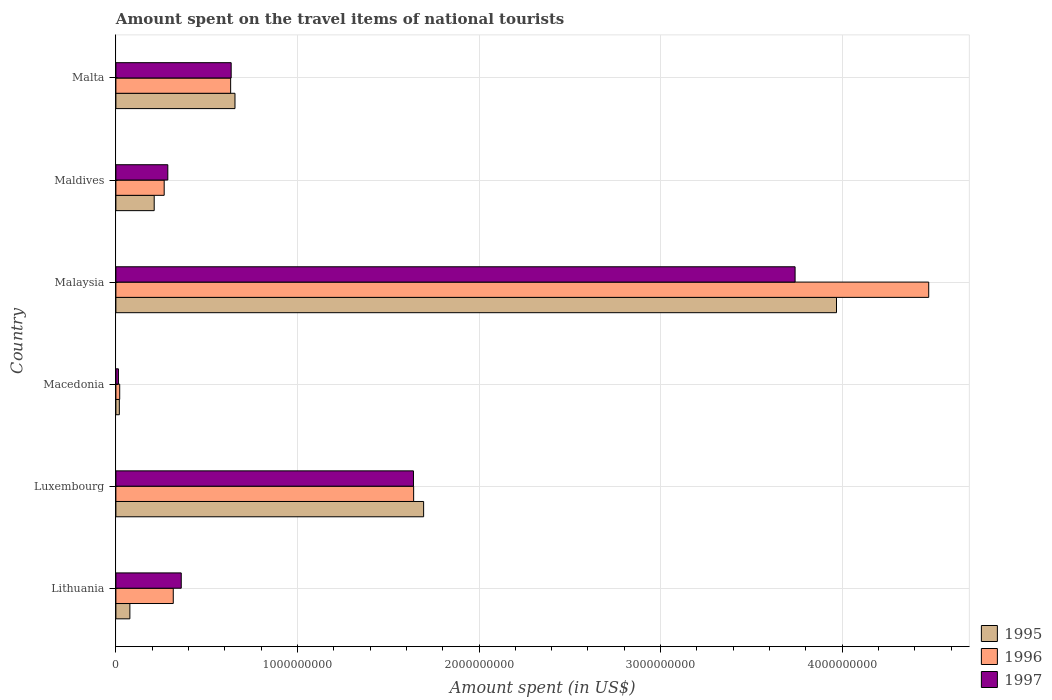How many different coloured bars are there?
Offer a terse response. 3. How many groups of bars are there?
Make the answer very short. 6. Are the number of bars per tick equal to the number of legend labels?
Make the answer very short. Yes. How many bars are there on the 2nd tick from the top?
Make the answer very short. 3. How many bars are there on the 2nd tick from the bottom?
Your answer should be compact. 3. What is the label of the 1st group of bars from the top?
Keep it short and to the point. Malta. What is the amount spent on the travel items of national tourists in 1996 in Malta?
Keep it short and to the point. 6.32e+08. Across all countries, what is the maximum amount spent on the travel items of national tourists in 1995?
Give a very brief answer. 3.97e+09. Across all countries, what is the minimum amount spent on the travel items of national tourists in 1997?
Keep it short and to the point. 1.40e+07. In which country was the amount spent on the travel items of national tourists in 1997 maximum?
Make the answer very short. Malaysia. In which country was the amount spent on the travel items of national tourists in 1995 minimum?
Make the answer very short. Macedonia. What is the total amount spent on the travel items of national tourists in 1997 in the graph?
Your response must be concise. 6.68e+09. What is the difference between the amount spent on the travel items of national tourists in 1996 in Macedonia and that in Malta?
Your response must be concise. -6.11e+08. What is the difference between the amount spent on the travel items of national tourists in 1995 in Malaysia and the amount spent on the travel items of national tourists in 1996 in Lithuania?
Your response must be concise. 3.65e+09. What is the average amount spent on the travel items of national tourists in 1996 per country?
Offer a very short reply. 1.23e+09. What is the difference between the amount spent on the travel items of national tourists in 1995 and amount spent on the travel items of national tourists in 1996 in Maldives?
Offer a very short reply. -5.50e+07. What is the ratio of the amount spent on the travel items of national tourists in 1996 in Lithuania to that in Luxembourg?
Make the answer very short. 0.19. What is the difference between the highest and the second highest amount spent on the travel items of national tourists in 1996?
Your response must be concise. 2.84e+09. What is the difference between the highest and the lowest amount spent on the travel items of national tourists in 1995?
Give a very brief answer. 3.95e+09. In how many countries, is the amount spent on the travel items of national tourists in 1997 greater than the average amount spent on the travel items of national tourists in 1997 taken over all countries?
Provide a short and direct response. 2. Is the sum of the amount spent on the travel items of national tourists in 1997 in Macedonia and Malta greater than the maximum amount spent on the travel items of national tourists in 1995 across all countries?
Give a very brief answer. No. What does the 1st bar from the bottom in Lithuania represents?
Keep it short and to the point. 1995. Are all the bars in the graph horizontal?
Your answer should be compact. Yes. How many countries are there in the graph?
Ensure brevity in your answer.  6. Does the graph contain any zero values?
Make the answer very short. No. Does the graph contain grids?
Your response must be concise. Yes. What is the title of the graph?
Ensure brevity in your answer.  Amount spent on the travel items of national tourists. Does "1962" appear as one of the legend labels in the graph?
Provide a succinct answer. No. What is the label or title of the X-axis?
Ensure brevity in your answer.  Amount spent (in US$). What is the Amount spent (in US$) in 1995 in Lithuania?
Your response must be concise. 7.70e+07. What is the Amount spent (in US$) in 1996 in Lithuania?
Provide a succinct answer. 3.16e+08. What is the Amount spent (in US$) of 1997 in Lithuania?
Provide a short and direct response. 3.60e+08. What is the Amount spent (in US$) of 1995 in Luxembourg?
Your answer should be compact. 1.70e+09. What is the Amount spent (in US$) of 1996 in Luxembourg?
Offer a terse response. 1.64e+09. What is the Amount spent (in US$) in 1997 in Luxembourg?
Make the answer very short. 1.64e+09. What is the Amount spent (in US$) in 1995 in Macedonia?
Your answer should be very brief. 1.90e+07. What is the Amount spent (in US$) of 1996 in Macedonia?
Offer a very short reply. 2.10e+07. What is the Amount spent (in US$) in 1997 in Macedonia?
Provide a short and direct response. 1.40e+07. What is the Amount spent (in US$) of 1995 in Malaysia?
Make the answer very short. 3.97e+09. What is the Amount spent (in US$) in 1996 in Malaysia?
Provide a short and direct response. 4.48e+09. What is the Amount spent (in US$) in 1997 in Malaysia?
Provide a succinct answer. 3.74e+09. What is the Amount spent (in US$) in 1995 in Maldives?
Provide a succinct answer. 2.11e+08. What is the Amount spent (in US$) of 1996 in Maldives?
Offer a very short reply. 2.66e+08. What is the Amount spent (in US$) in 1997 in Maldives?
Your response must be concise. 2.86e+08. What is the Amount spent (in US$) of 1995 in Malta?
Ensure brevity in your answer.  6.56e+08. What is the Amount spent (in US$) of 1996 in Malta?
Keep it short and to the point. 6.32e+08. What is the Amount spent (in US$) of 1997 in Malta?
Keep it short and to the point. 6.35e+08. Across all countries, what is the maximum Amount spent (in US$) in 1995?
Provide a succinct answer. 3.97e+09. Across all countries, what is the maximum Amount spent (in US$) in 1996?
Offer a very short reply. 4.48e+09. Across all countries, what is the maximum Amount spent (in US$) in 1997?
Your response must be concise. 3.74e+09. Across all countries, what is the minimum Amount spent (in US$) of 1995?
Your answer should be very brief. 1.90e+07. Across all countries, what is the minimum Amount spent (in US$) of 1996?
Your answer should be very brief. 2.10e+07. Across all countries, what is the minimum Amount spent (in US$) in 1997?
Your answer should be compact. 1.40e+07. What is the total Amount spent (in US$) of 1995 in the graph?
Your answer should be very brief. 6.63e+09. What is the total Amount spent (in US$) of 1996 in the graph?
Provide a short and direct response. 7.35e+09. What is the total Amount spent (in US$) in 1997 in the graph?
Offer a very short reply. 6.68e+09. What is the difference between the Amount spent (in US$) of 1995 in Lithuania and that in Luxembourg?
Make the answer very short. -1.62e+09. What is the difference between the Amount spent (in US$) of 1996 in Lithuania and that in Luxembourg?
Provide a succinct answer. -1.32e+09. What is the difference between the Amount spent (in US$) of 1997 in Lithuania and that in Luxembourg?
Offer a terse response. -1.28e+09. What is the difference between the Amount spent (in US$) in 1995 in Lithuania and that in Macedonia?
Offer a terse response. 5.80e+07. What is the difference between the Amount spent (in US$) in 1996 in Lithuania and that in Macedonia?
Give a very brief answer. 2.95e+08. What is the difference between the Amount spent (in US$) of 1997 in Lithuania and that in Macedonia?
Provide a short and direct response. 3.46e+08. What is the difference between the Amount spent (in US$) of 1995 in Lithuania and that in Malaysia?
Offer a very short reply. -3.89e+09. What is the difference between the Amount spent (in US$) in 1996 in Lithuania and that in Malaysia?
Your answer should be very brief. -4.16e+09. What is the difference between the Amount spent (in US$) of 1997 in Lithuania and that in Malaysia?
Make the answer very short. -3.38e+09. What is the difference between the Amount spent (in US$) of 1995 in Lithuania and that in Maldives?
Give a very brief answer. -1.34e+08. What is the difference between the Amount spent (in US$) of 1996 in Lithuania and that in Maldives?
Make the answer very short. 5.00e+07. What is the difference between the Amount spent (in US$) of 1997 in Lithuania and that in Maldives?
Your answer should be compact. 7.40e+07. What is the difference between the Amount spent (in US$) in 1995 in Lithuania and that in Malta?
Keep it short and to the point. -5.79e+08. What is the difference between the Amount spent (in US$) in 1996 in Lithuania and that in Malta?
Provide a short and direct response. -3.16e+08. What is the difference between the Amount spent (in US$) in 1997 in Lithuania and that in Malta?
Your answer should be compact. -2.75e+08. What is the difference between the Amount spent (in US$) in 1995 in Luxembourg and that in Macedonia?
Ensure brevity in your answer.  1.68e+09. What is the difference between the Amount spent (in US$) in 1996 in Luxembourg and that in Macedonia?
Provide a short and direct response. 1.62e+09. What is the difference between the Amount spent (in US$) of 1997 in Luxembourg and that in Macedonia?
Offer a terse response. 1.62e+09. What is the difference between the Amount spent (in US$) in 1995 in Luxembourg and that in Malaysia?
Offer a terse response. -2.27e+09. What is the difference between the Amount spent (in US$) in 1996 in Luxembourg and that in Malaysia?
Your response must be concise. -2.84e+09. What is the difference between the Amount spent (in US$) of 1997 in Luxembourg and that in Malaysia?
Make the answer very short. -2.10e+09. What is the difference between the Amount spent (in US$) in 1995 in Luxembourg and that in Maldives?
Provide a short and direct response. 1.48e+09. What is the difference between the Amount spent (in US$) of 1996 in Luxembourg and that in Maldives?
Offer a terse response. 1.37e+09. What is the difference between the Amount spent (in US$) in 1997 in Luxembourg and that in Maldives?
Your answer should be compact. 1.35e+09. What is the difference between the Amount spent (in US$) in 1995 in Luxembourg and that in Malta?
Ensure brevity in your answer.  1.04e+09. What is the difference between the Amount spent (in US$) in 1996 in Luxembourg and that in Malta?
Offer a very short reply. 1.01e+09. What is the difference between the Amount spent (in US$) in 1997 in Luxembourg and that in Malta?
Your answer should be compact. 1.00e+09. What is the difference between the Amount spent (in US$) in 1995 in Macedonia and that in Malaysia?
Ensure brevity in your answer.  -3.95e+09. What is the difference between the Amount spent (in US$) in 1996 in Macedonia and that in Malaysia?
Your answer should be very brief. -4.46e+09. What is the difference between the Amount spent (in US$) in 1997 in Macedonia and that in Malaysia?
Your response must be concise. -3.73e+09. What is the difference between the Amount spent (in US$) in 1995 in Macedonia and that in Maldives?
Offer a very short reply. -1.92e+08. What is the difference between the Amount spent (in US$) in 1996 in Macedonia and that in Maldives?
Ensure brevity in your answer.  -2.45e+08. What is the difference between the Amount spent (in US$) of 1997 in Macedonia and that in Maldives?
Ensure brevity in your answer.  -2.72e+08. What is the difference between the Amount spent (in US$) of 1995 in Macedonia and that in Malta?
Provide a short and direct response. -6.37e+08. What is the difference between the Amount spent (in US$) of 1996 in Macedonia and that in Malta?
Your answer should be very brief. -6.11e+08. What is the difference between the Amount spent (in US$) in 1997 in Macedonia and that in Malta?
Offer a terse response. -6.21e+08. What is the difference between the Amount spent (in US$) in 1995 in Malaysia and that in Maldives?
Your response must be concise. 3.76e+09. What is the difference between the Amount spent (in US$) in 1996 in Malaysia and that in Maldives?
Keep it short and to the point. 4.21e+09. What is the difference between the Amount spent (in US$) of 1997 in Malaysia and that in Maldives?
Offer a very short reply. 3.46e+09. What is the difference between the Amount spent (in US$) in 1995 in Malaysia and that in Malta?
Provide a succinct answer. 3.31e+09. What is the difference between the Amount spent (in US$) of 1996 in Malaysia and that in Malta?
Give a very brief answer. 3.84e+09. What is the difference between the Amount spent (in US$) in 1997 in Malaysia and that in Malta?
Give a very brief answer. 3.11e+09. What is the difference between the Amount spent (in US$) in 1995 in Maldives and that in Malta?
Give a very brief answer. -4.45e+08. What is the difference between the Amount spent (in US$) of 1996 in Maldives and that in Malta?
Your response must be concise. -3.66e+08. What is the difference between the Amount spent (in US$) of 1997 in Maldives and that in Malta?
Your answer should be very brief. -3.49e+08. What is the difference between the Amount spent (in US$) of 1995 in Lithuania and the Amount spent (in US$) of 1996 in Luxembourg?
Provide a succinct answer. -1.56e+09. What is the difference between the Amount spent (in US$) in 1995 in Lithuania and the Amount spent (in US$) in 1997 in Luxembourg?
Your response must be concise. -1.56e+09. What is the difference between the Amount spent (in US$) in 1996 in Lithuania and the Amount spent (in US$) in 1997 in Luxembourg?
Keep it short and to the point. -1.32e+09. What is the difference between the Amount spent (in US$) of 1995 in Lithuania and the Amount spent (in US$) of 1996 in Macedonia?
Provide a succinct answer. 5.60e+07. What is the difference between the Amount spent (in US$) of 1995 in Lithuania and the Amount spent (in US$) of 1997 in Macedonia?
Your answer should be very brief. 6.30e+07. What is the difference between the Amount spent (in US$) of 1996 in Lithuania and the Amount spent (in US$) of 1997 in Macedonia?
Give a very brief answer. 3.02e+08. What is the difference between the Amount spent (in US$) of 1995 in Lithuania and the Amount spent (in US$) of 1996 in Malaysia?
Offer a terse response. -4.40e+09. What is the difference between the Amount spent (in US$) in 1995 in Lithuania and the Amount spent (in US$) in 1997 in Malaysia?
Offer a terse response. -3.66e+09. What is the difference between the Amount spent (in US$) of 1996 in Lithuania and the Amount spent (in US$) of 1997 in Malaysia?
Your answer should be very brief. -3.42e+09. What is the difference between the Amount spent (in US$) in 1995 in Lithuania and the Amount spent (in US$) in 1996 in Maldives?
Keep it short and to the point. -1.89e+08. What is the difference between the Amount spent (in US$) of 1995 in Lithuania and the Amount spent (in US$) of 1997 in Maldives?
Offer a terse response. -2.09e+08. What is the difference between the Amount spent (in US$) of 1996 in Lithuania and the Amount spent (in US$) of 1997 in Maldives?
Make the answer very short. 3.00e+07. What is the difference between the Amount spent (in US$) in 1995 in Lithuania and the Amount spent (in US$) in 1996 in Malta?
Keep it short and to the point. -5.55e+08. What is the difference between the Amount spent (in US$) of 1995 in Lithuania and the Amount spent (in US$) of 1997 in Malta?
Your response must be concise. -5.58e+08. What is the difference between the Amount spent (in US$) in 1996 in Lithuania and the Amount spent (in US$) in 1997 in Malta?
Your response must be concise. -3.19e+08. What is the difference between the Amount spent (in US$) of 1995 in Luxembourg and the Amount spent (in US$) of 1996 in Macedonia?
Your response must be concise. 1.67e+09. What is the difference between the Amount spent (in US$) in 1995 in Luxembourg and the Amount spent (in US$) in 1997 in Macedonia?
Provide a succinct answer. 1.68e+09. What is the difference between the Amount spent (in US$) in 1996 in Luxembourg and the Amount spent (in US$) in 1997 in Macedonia?
Your answer should be very brief. 1.63e+09. What is the difference between the Amount spent (in US$) in 1995 in Luxembourg and the Amount spent (in US$) in 1996 in Malaysia?
Give a very brief answer. -2.78e+09. What is the difference between the Amount spent (in US$) in 1995 in Luxembourg and the Amount spent (in US$) in 1997 in Malaysia?
Offer a terse response. -2.05e+09. What is the difference between the Amount spent (in US$) in 1996 in Luxembourg and the Amount spent (in US$) in 1997 in Malaysia?
Provide a succinct answer. -2.10e+09. What is the difference between the Amount spent (in US$) of 1995 in Luxembourg and the Amount spent (in US$) of 1996 in Maldives?
Offer a very short reply. 1.43e+09. What is the difference between the Amount spent (in US$) in 1995 in Luxembourg and the Amount spent (in US$) in 1997 in Maldives?
Provide a short and direct response. 1.41e+09. What is the difference between the Amount spent (in US$) in 1996 in Luxembourg and the Amount spent (in US$) in 1997 in Maldives?
Your answer should be very brief. 1.35e+09. What is the difference between the Amount spent (in US$) of 1995 in Luxembourg and the Amount spent (in US$) of 1996 in Malta?
Offer a very short reply. 1.06e+09. What is the difference between the Amount spent (in US$) in 1995 in Luxembourg and the Amount spent (in US$) in 1997 in Malta?
Your answer should be compact. 1.06e+09. What is the difference between the Amount spent (in US$) in 1996 in Luxembourg and the Amount spent (in US$) in 1997 in Malta?
Your answer should be very brief. 1.00e+09. What is the difference between the Amount spent (in US$) in 1995 in Macedonia and the Amount spent (in US$) in 1996 in Malaysia?
Provide a short and direct response. -4.46e+09. What is the difference between the Amount spent (in US$) of 1995 in Macedonia and the Amount spent (in US$) of 1997 in Malaysia?
Your answer should be very brief. -3.72e+09. What is the difference between the Amount spent (in US$) in 1996 in Macedonia and the Amount spent (in US$) in 1997 in Malaysia?
Give a very brief answer. -3.72e+09. What is the difference between the Amount spent (in US$) of 1995 in Macedonia and the Amount spent (in US$) of 1996 in Maldives?
Give a very brief answer. -2.47e+08. What is the difference between the Amount spent (in US$) of 1995 in Macedonia and the Amount spent (in US$) of 1997 in Maldives?
Provide a succinct answer. -2.67e+08. What is the difference between the Amount spent (in US$) in 1996 in Macedonia and the Amount spent (in US$) in 1997 in Maldives?
Your answer should be compact. -2.65e+08. What is the difference between the Amount spent (in US$) of 1995 in Macedonia and the Amount spent (in US$) of 1996 in Malta?
Your response must be concise. -6.13e+08. What is the difference between the Amount spent (in US$) in 1995 in Macedonia and the Amount spent (in US$) in 1997 in Malta?
Provide a succinct answer. -6.16e+08. What is the difference between the Amount spent (in US$) in 1996 in Macedonia and the Amount spent (in US$) in 1997 in Malta?
Your answer should be compact. -6.14e+08. What is the difference between the Amount spent (in US$) in 1995 in Malaysia and the Amount spent (in US$) in 1996 in Maldives?
Your answer should be very brief. 3.70e+09. What is the difference between the Amount spent (in US$) of 1995 in Malaysia and the Amount spent (in US$) of 1997 in Maldives?
Provide a short and direct response. 3.68e+09. What is the difference between the Amount spent (in US$) of 1996 in Malaysia and the Amount spent (in US$) of 1997 in Maldives?
Your response must be concise. 4.19e+09. What is the difference between the Amount spent (in US$) of 1995 in Malaysia and the Amount spent (in US$) of 1996 in Malta?
Ensure brevity in your answer.  3.34e+09. What is the difference between the Amount spent (in US$) in 1995 in Malaysia and the Amount spent (in US$) in 1997 in Malta?
Offer a very short reply. 3.33e+09. What is the difference between the Amount spent (in US$) of 1996 in Malaysia and the Amount spent (in US$) of 1997 in Malta?
Ensure brevity in your answer.  3.84e+09. What is the difference between the Amount spent (in US$) in 1995 in Maldives and the Amount spent (in US$) in 1996 in Malta?
Keep it short and to the point. -4.21e+08. What is the difference between the Amount spent (in US$) of 1995 in Maldives and the Amount spent (in US$) of 1997 in Malta?
Your answer should be compact. -4.24e+08. What is the difference between the Amount spent (in US$) of 1996 in Maldives and the Amount spent (in US$) of 1997 in Malta?
Your response must be concise. -3.69e+08. What is the average Amount spent (in US$) in 1995 per country?
Offer a very short reply. 1.10e+09. What is the average Amount spent (in US$) of 1996 per country?
Keep it short and to the point. 1.23e+09. What is the average Amount spent (in US$) of 1997 per country?
Keep it short and to the point. 1.11e+09. What is the difference between the Amount spent (in US$) in 1995 and Amount spent (in US$) in 1996 in Lithuania?
Keep it short and to the point. -2.39e+08. What is the difference between the Amount spent (in US$) of 1995 and Amount spent (in US$) of 1997 in Lithuania?
Provide a succinct answer. -2.83e+08. What is the difference between the Amount spent (in US$) of 1996 and Amount spent (in US$) of 1997 in Lithuania?
Your answer should be very brief. -4.40e+07. What is the difference between the Amount spent (in US$) of 1995 and Amount spent (in US$) of 1996 in Luxembourg?
Offer a very short reply. 5.50e+07. What is the difference between the Amount spent (in US$) in 1995 and Amount spent (in US$) in 1997 in Luxembourg?
Make the answer very short. 5.60e+07. What is the difference between the Amount spent (in US$) of 1996 and Amount spent (in US$) of 1997 in Luxembourg?
Your answer should be very brief. 1.00e+06. What is the difference between the Amount spent (in US$) of 1995 and Amount spent (in US$) of 1996 in Macedonia?
Offer a very short reply. -2.00e+06. What is the difference between the Amount spent (in US$) in 1995 and Amount spent (in US$) in 1997 in Macedonia?
Keep it short and to the point. 5.00e+06. What is the difference between the Amount spent (in US$) in 1996 and Amount spent (in US$) in 1997 in Macedonia?
Give a very brief answer. 7.00e+06. What is the difference between the Amount spent (in US$) of 1995 and Amount spent (in US$) of 1996 in Malaysia?
Offer a very short reply. -5.08e+08. What is the difference between the Amount spent (in US$) in 1995 and Amount spent (in US$) in 1997 in Malaysia?
Your answer should be very brief. 2.28e+08. What is the difference between the Amount spent (in US$) of 1996 and Amount spent (in US$) of 1997 in Malaysia?
Keep it short and to the point. 7.36e+08. What is the difference between the Amount spent (in US$) of 1995 and Amount spent (in US$) of 1996 in Maldives?
Offer a terse response. -5.50e+07. What is the difference between the Amount spent (in US$) in 1995 and Amount spent (in US$) in 1997 in Maldives?
Give a very brief answer. -7.50e+07. What is the difference between the Amount spent (in US$) in 1996 and Amount spent (in US$) in 1997 in Maldives?
Keep it short and to the point. -2.00e+07. What is the difference between the Amount spent (in US$) in 1995 and Amount spent (in US$) in 1996 in Malta?
Your answer should be very brief. 2.40e+07. What is the difference between the Amount spent (in US$) in 1995 and Amount spent (in US$) in 1997 in Malta?
Your response must be concise. 2.10e+07. What is the difference between the Amount spent (in US$) in 1996 and Amount spent (in US$) in 1997 in Malta?
Offer a terse response. -3.00e+06. What is the ratio of the Amount spent (in US$) of 1995 in Lithuania to that in Luxembourg?
Your answer should be compact. 0.05. What is the ratio of the Amount spent (in US$) of 1996 in Lithuania to that in Luxembourg?
Ensure brevity in your answer.  0.19. What is the ratio of the Amount spent (in US$) in 1997 in Lithuania to that in Luxembourg?
Give a very brief answer. 0.22. What is the ratio of the Amount spent (in US$) of 1995 in Lithuania to that in Macedonia?
Keep it short and to the point. 4.05. What is the ratio of the Amount spent (in US$) in 1996 in Lithuania to that in Macedonia?
Offer a very short reply. 15.05. What is the ratio of the Amount spent (in US$) in 1997 in Lithuania to that in Macedonia?
Keep it short and to the point. 25.71. What is the ratio of the Amount spent (in US$) of 1995 in Lithuania to that in Malaysia?
Your response must be concise. 0.02. What is the ratio of the Amount spent (in US$) of 1996 in Lithuania to that in Malaysia?
Make the answer very short. 0.07. What is the ratio of the Amount spent (in US$) of 1997 in Lithuania to that in Malaysia?
Provide a succinct answer. 0.1. What is the ratio of the Amount spent (in US$) in 1995 in Lithuania to that in Maldives?
Your response must be concise. 0.36. What is the ratio of the Amount spent (in US$) of 1996 in Lithuania to that in Maldives?
Your response must be concise. 1.19. What is the ratio of the Amount spent (in US$) in 1997 in Lithuania to that in Maldives?
Give a very brief answer. 1.26. What is the ratio of the Amount spent (in US$) of 1995 in Lithuania to that in Malta?
Keep it short and to the point. 0.12. What is the ratio of the Amount spent (in US$) in 1997 in Lithuania to that in Malta?
Your answer should be very brief. 0.57. What is the ratio of the Amount spent (in US$) of 1995 in Luxembourg to that in Macedonia?
Your answer should be very brief. 89.21. What is the ratio of the Amount spent (in US$) of 1996 in Luxembourg to that in Macedonia?
Offer a terse response. 78.1. What is the ratio of the Amount spent (in US$) of 1997 in Luxembourg to that in Macedonia?
Provide a short and direct response. 117.07. What is the ratio of the Amount spent (in US$) in 1995 in Luxembourg to that in Malaysia?
Offer a very short reply. 0.43. What is the ratio of the Amount spent (in US$) of 1996 in Luxembourg to that in Malaysia?
Your answer should be very brief. 0.37. What is the ratio of the Amount spent (in US$) in 1997 in Luxembourg to that in Malaysia?
Your answer should be compact. 0.44. What is the ratio of the Amount spent (in US$) in 1995 in Luxembourg to that in Maldives?
Ensure brevity in your answer.  8.03. What is the ratio of the Amount spent (in US$) in 1996 in Luxembourg to that in Maldives?
Offer a very short reply. 6.17. What is the ratio of the Amount spent (in US$) of 1997 in Luxembourg to that in Maldives?
Your response must be concise. 5.73. What is the ratio of the Amount spent (in US$) in 1995 in Luxembourg to that in Malta?
Offer a terse response. 2.58. What is the ratio of the Amount spent (in US$) of 1996 in Luxembourg to that in Malta?
Your answer should be very brief. 2.59. What is the ratio of the Amount spent (in US$) in 1997 in Luxembourg to that in Malta?
Provide a succinct answer. 2.58. What is the ratio of the Amount spent (in US$) of 1995 in Macedonia to that in Malaysia?
Provide a short and direct response. 0. What is the ratio of the Amount spent (in US$) in 1996 in Macedonia to that in Malaysia?
Give a very brief answer. 0. What is the ratio of the Amount spent (in US$) of 1997 in Macedonia to that in Malaysia?
Offer a very short reply. 0. What is the ratio of the Amount spent (in US$) of 1995 in Macedonia to that in Maldives?
Your answer should be very brief. 0.09. What is the ratio of the Amount spent (in US$) of 1996 in Macedonia to that in Maldives?
Give a very brief answer. 0.08. What is the ratio of the Amount spent (in US$) in 1997 in Macedonia to that in Maldives?
Your answer should be compact. 0.05. What is the ratio of the Amount spent (in US$) in 1995 in Macedonia to that in Malta?
Provide a succinct answer. 0.03. What is the ratio of the Amount spent (in US$) of 1996 in Macedonia to that in Malta?
Make the answer very short. 0.03. What is the ratio of the Amount spent (in US$) of 1997 in Macedonia to that in Malta?
Provide a short and direct response. 0.02. What is the ratio of the Amount spent (in US$) in 1995 in Malaysia to that in Maldives?
Offer a very short reply. 18.81. What is the ratio of the Amount spent (in US$) of 1996 in Malaysia to that in Maldives?
Your response must be concise. 16.83. What is the ratio of the Amount spent (in US$) in 1997 in Malaysia to that in Maldives?
Your answer should be compact. 13.08. What is the ratio of the Amount spent (in US$) in 1995 in Malaysia to that in Malta?
Your answer should be compact. 6.05. What is the ratio of the Amount spent (in US$) of 1996 in Malaysia to that in Malta?
Offer a terse response. 7.08. What is the ratio of the Amount spent (in US$) of 1997 in Malaysia to that in Malta?
Keep it short and to the point. 5.89. What is the ratio of the Amount spent (in US$) in 1995 in Maldives to that in Malta?
Provide a succinct answer. 0.32. What is the ratio of the Amount spent (in US$) of 1996 in Maldives to that in Malta?
Offer a very short reply. 0.42. What is the ratio of the Amount spent (in US$) in 1997 in Maldives to that in Malta?
Offer a very short reply. 0.45. What is the difference between the highest and the second highest Amount spent (in US$) in 1995?
Provide a succinct answer. 2.27e+09. What is the difference between the highest and the second highest Amount spent (in US$) in 1996?
Your answer should be very brief. 2.84e+09. What is the difference between the highest and the second highest Amount spent (in US$) in 1997?
Your answer should be very brief. 2.10e+09. What is the difference between the highest and the lowest Amount spent (in US$) of 1995?
Provide a short and direct response. 3.95e+09. What is the difference between the highest and the lowest Amount spent (in US$) of 1996?
Ensure brevity in your answer.  4.46e+09. What is the difference between the highest and the lowest Amount spent (in US$) in 1997?
Make the answer very short. 3.73e+09. 